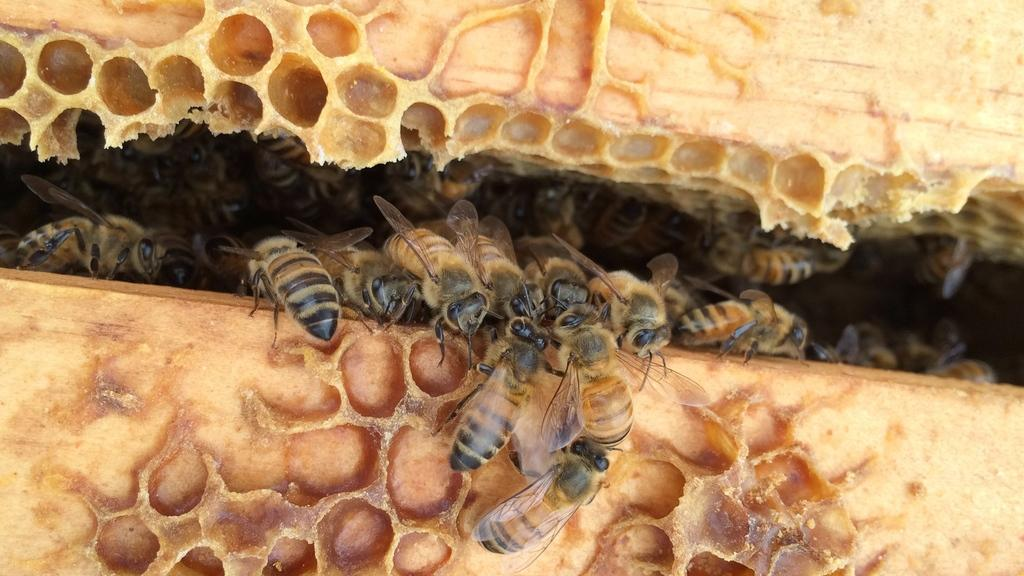What type of creatures are present in the image? There are insects in the image. Can you describe the insects in more detail? The insects resemble honey bees. Where are the honey bees located in the image? The honey bees are in a bee hive. What type of steel part can be seen in the image? There is no steel part present in the image; it features insects resembling honey bees in a bee hive. 